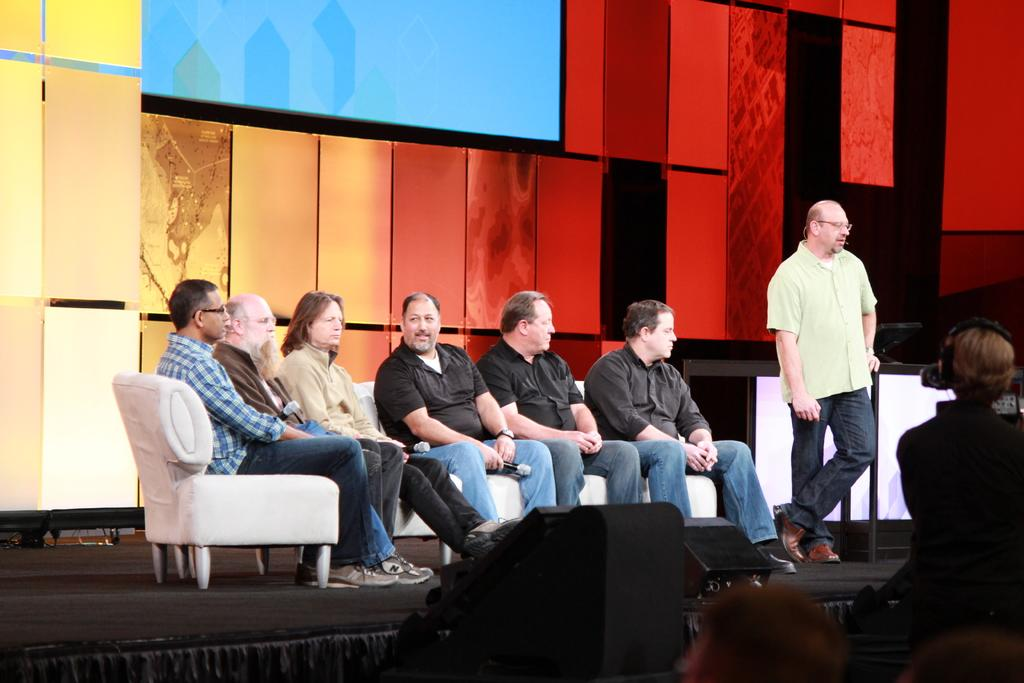What are the people in the image doing? The people in the image are sitting on a couch. What can be seen in the background of the image? There is a glass wall and a screen in the background of the image. What type of stick is being used by the people sitting on the couch in the image? There is no stick present in the image; the people are simply sitting on the couch. Can you see a donkey in the image? No, there is no donkey present in the image. 